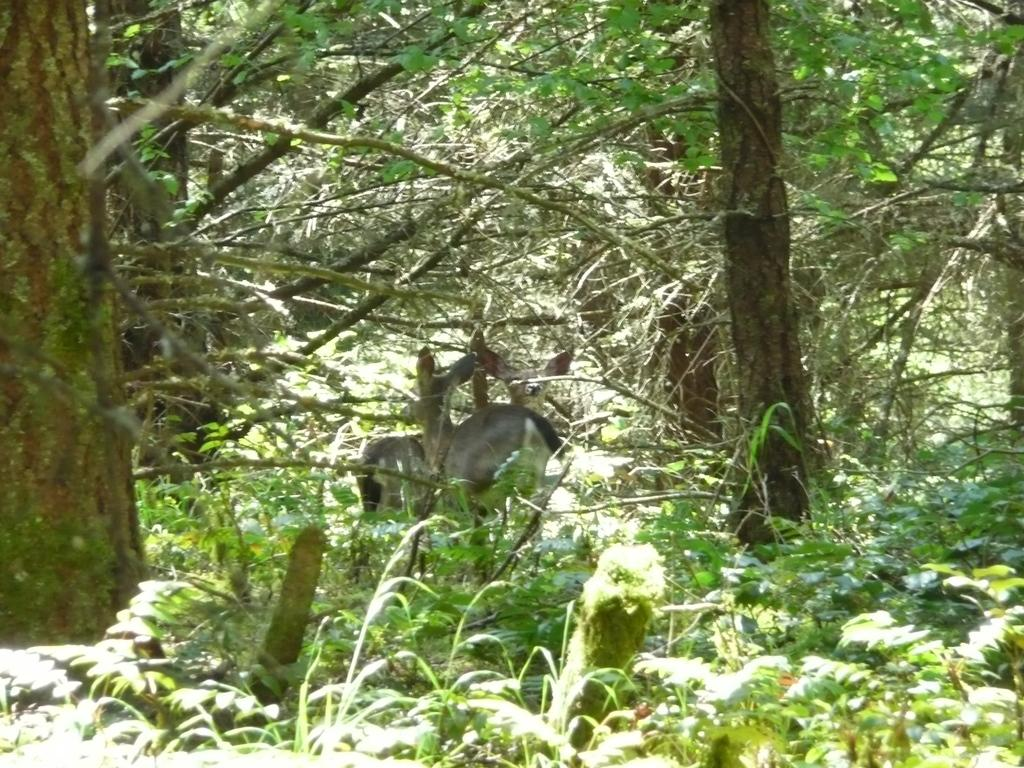How many animals are present in the image? There are two animals in the image. Where are the animals located in the image? The animals are on a path in the image. What can be seen in the background of the image? There are trees and plants in the background of the image. What type of behavior can be observed in the animals' heads in the image? There is no mention of the animals' heads or any specific behavior in the image. 